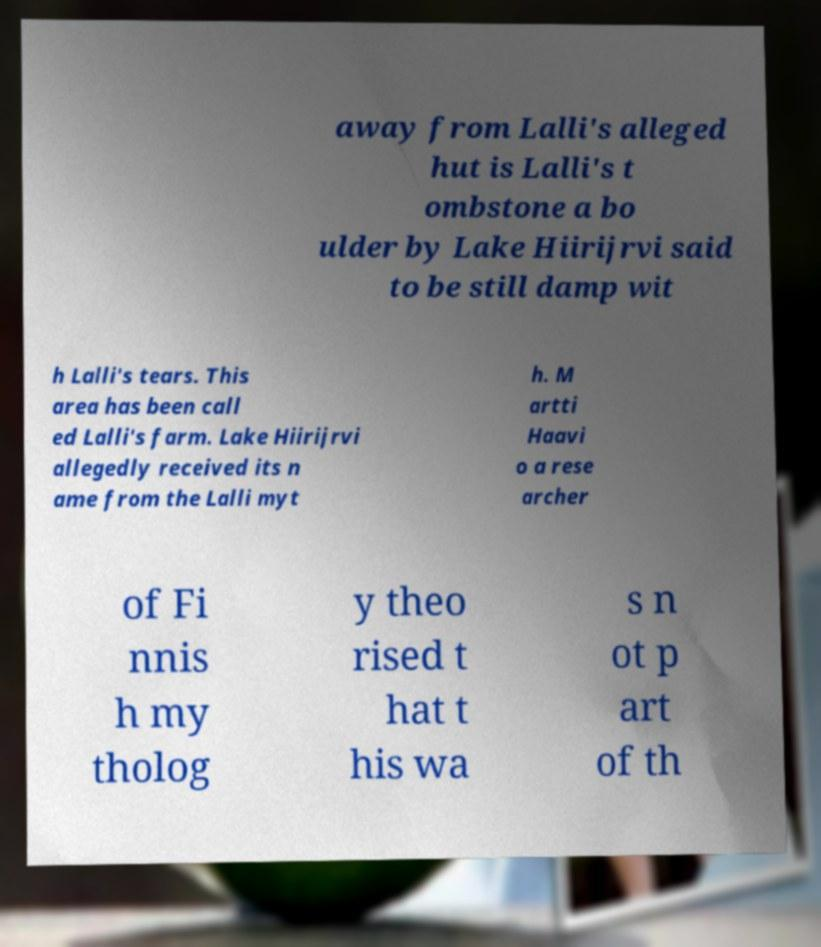Could you assist in decoding the text presented in this image and type it out clearly? away from Lalli's alleged hut is Lalli's t ombstone a bo ulder by Lake Hiirijrvi said to be still damp wit h Lalli's tears. This area has been call ed Lalli's farm. Lake Hiirijrvi allegedly received its n ame from the Lalli myt h. M artti Haavi o a rese archer of Fi nnis h my tholog y theo rised t hat t his wa s n ot p art of th 